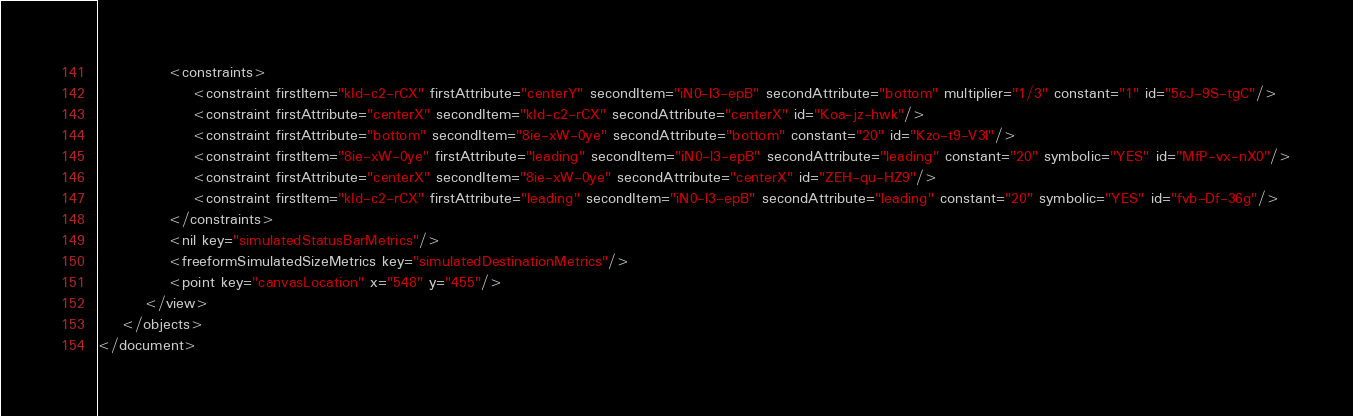Convert code to text. <code><loc_0><loc_0><loc_500><loc_500><_XML_>            <constraints>
                <constraint firstItem="kId-c2-rCX" firstAttribute="centerY" secondItem="iN0-l3-epB" secondAttribute="bottom" multiplier="1/3" constant="1" id="5cJ-9S-tgC"/>
                <constraint firstAttribute="centerX" secondItem="kId-c2-rCX" secondAttribute="centerX" id="Koa-jz-hwk"/>
                <constraint firstAttribute="bottom" secondItem="8ie-xW-0ye" secondAttribute="bottom" constant="20" id="Kzo-t9-V3l"/>
                <constraint firstItem="8ie-xW-0ye" firstAttribute="leading" secondItem="iN0-l3-epB" secondAttribute="leading" constant="20" symbolic="YES" id="MfP-vx-nX0"/>
                <constraint firstAttribute="centerX" secondItem="8ie-xW-0ye" secondAttribute="centerX" id="ZEH-qu-HZ9"/>
                <constraint firstItem="kId-c2-rCX" firstAttribute="leading" secondItem="iN0-l3-epB" secondAttribute="leading" constant="20" symbolic="YES" id="fvb-Df-36g"/>
            </constraints>
            <nil key="simulatedStatusBarMetrics"/>
            <freeformSimulatedSizeMetrics key="simulatedDestinationMetrics"/>
            <point key="canvasLocation" x="548" y="455"/>
        </view>
    </objects>
</document>
</code> 